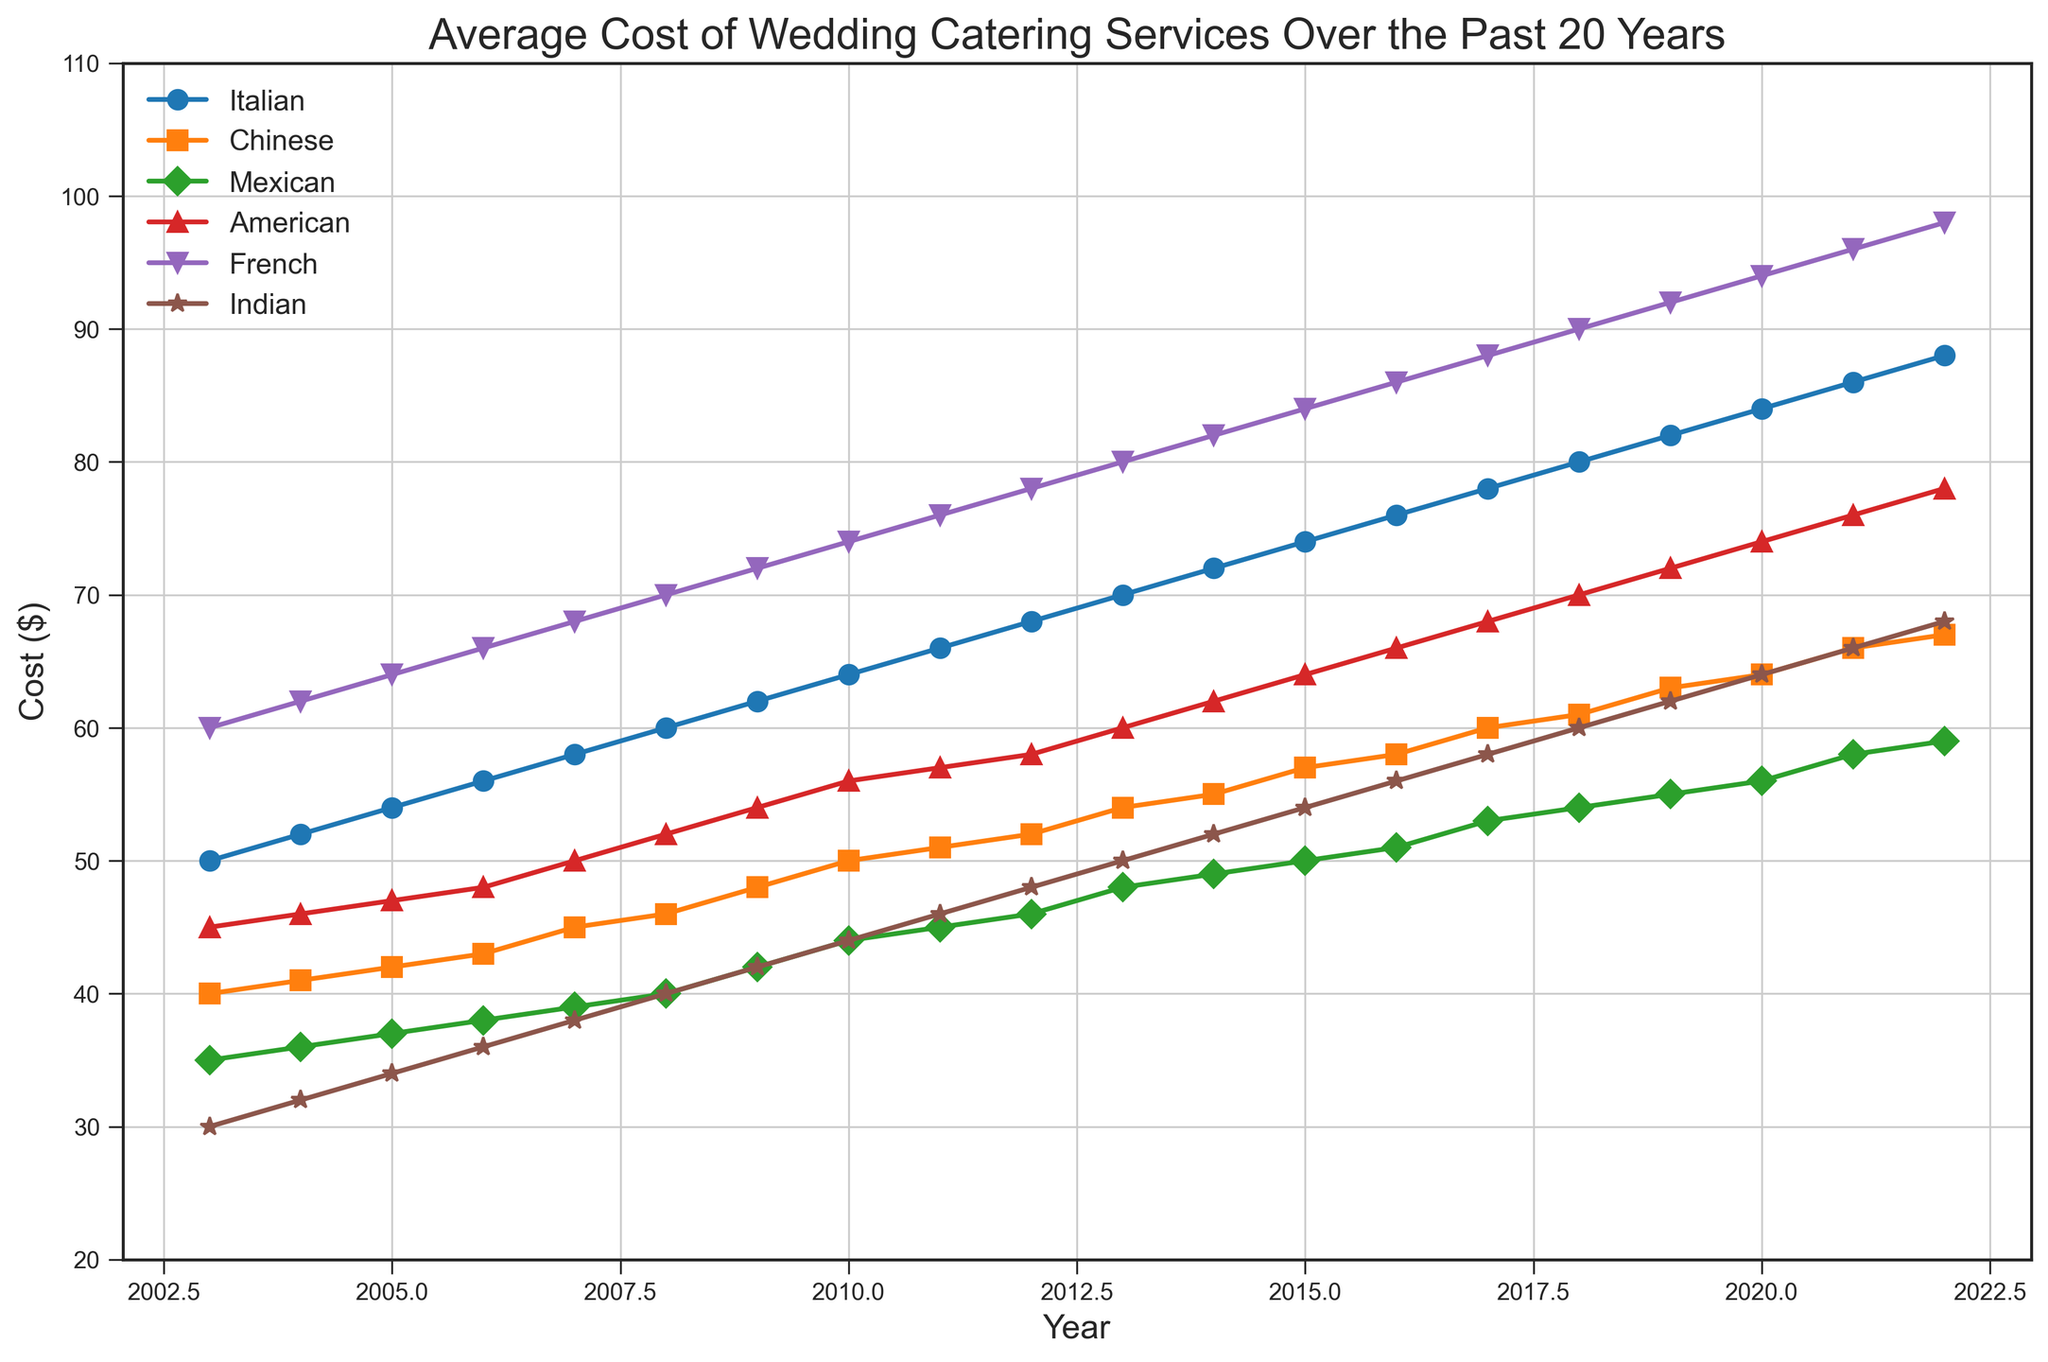How did the cost of French cuisine change from 2003 to 2022? From the chart, the cost of French cuisine in 2003 was $60, and it increased to $98 in 2022. Subtract the cost in 2003 from the cost in 2022: 98 - 60 = 38.
Answer: 38 Which cuisine had the highest average cost over the 20-year period? To find this, observe the trend lines and average out the costs across each cuisine. Visual inspection shows that French cuisine consistently remains the highest over the years.
Answer: French What year did Mexican cuisine surpass $50 in cost? Look at the Mexican cuisine line and identify the point where it crosses the $50 mark. This first happens between 2014 and 2015.
Answer: 2015 How did the cost trends of Italian and American cuisines compare over the period? Both cuisines show an upward trend, but Italian cuisine starts and ends with higher values compared to American. Italian ranges from $50 to $88, while American ranges from $45 to $78.
Answer: Italian is consistently higher In which year did Indian cuisine see the steepest rise in cost? Look for the steepest segment in the Indian cuisine line. This appears around 2017-2018, where cost jumps from $58 to $60.
Answer: 2017-2018 By how much did the cost of Chinese cuisine increase from 2009 to 2014? Cost in 2009 was $48, and in 2014 it was $55. Subtract the earlier value from the later value: 55 - 48 = 7.
Answer: 7 Which two cuisines had the closest costs in 2008, and what were their values? In 2008, Chinese and Mexican cuisines had very close costs of $46 and $40, respectively.
Answer: Chinese ($46) and Mexican ($40) What's the average cost of Indian cuisine over the 20-year period? Add the costs of Indian cuisine from each year and divide by the number of years (20). (30+32+34+36+38+40+42+44+46+48+50+52+54+56+58+60+62+64+66+68)/20 = 50.
Answer: 50 Did the cost of any cuisine remain below $50 throughout the period? Look at each cuisine’s line to see if it stayed below $50. Indian is consistently below $50 for all years except the last year (2022).
Answer: No Which year did American cuisine first exceed $60? Locate the point on the American cuisine line that first crosses $60. This happens between 2012 and 2013.
Answer: 2013 